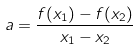<formula> <loc_0><loc_0><loc_500><loc_500>a = \frac { f ( x _ { 1 } ) - f ( x _ { 2 } ) } { x _ { 1 } - x _ { 2 } }</formula> 